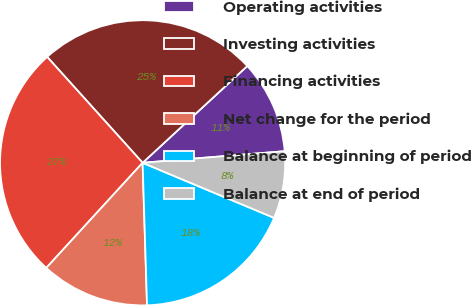Convert chart to OTSL. <chart><loc_0><loc_0><loc_500><loc_500><pie_chart><fcel>Operating activities<fcel>Investing activities<fcel>Financing activities<fcel>Net change for the period<fcel>Balance at beginning of period<fcel>Balance at end of period<nl><fcel>10.58%<fcel>24.8%<fcel>26.52%<fcel>12.3%<fcel>18.19%<fcel>7.61%<nl></chart> 